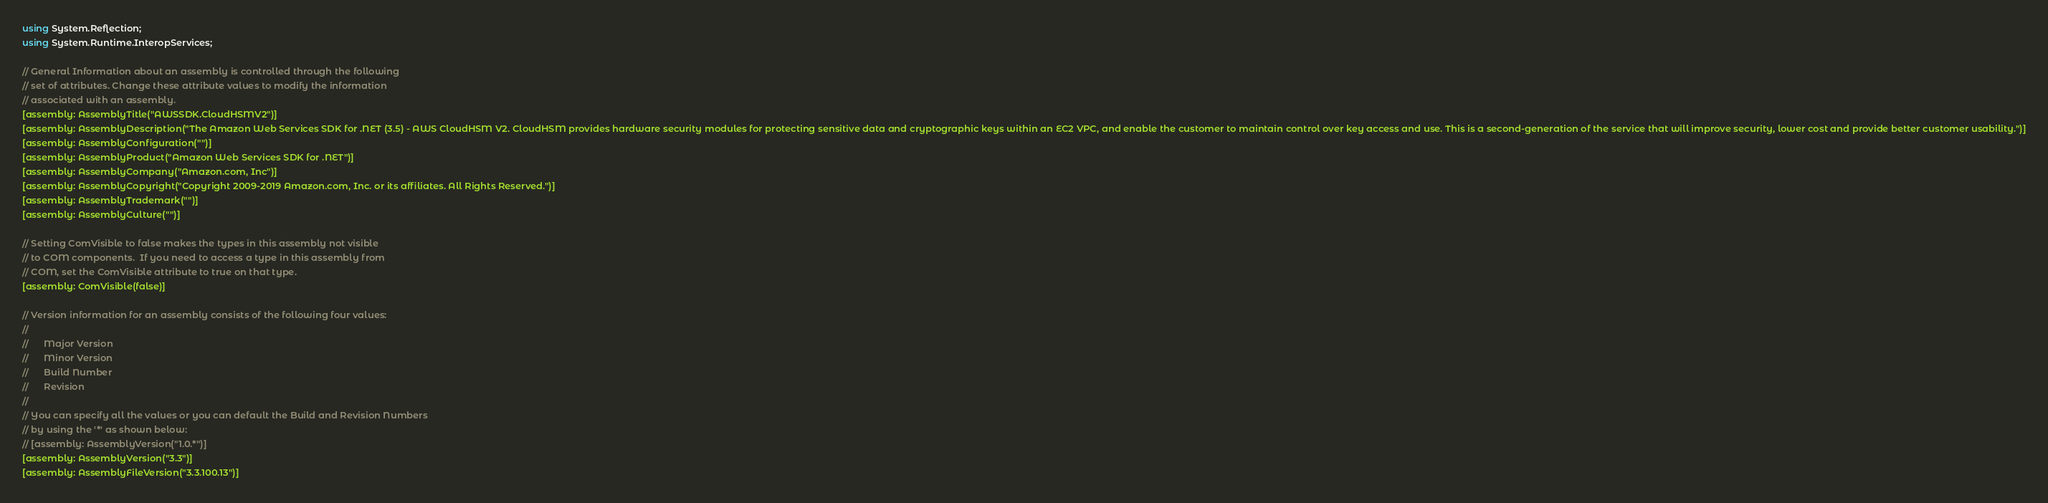<code> <loc_0><loc_0><loc_500><loc_500><_C#_>using System.Reflection;
using System.Runtime.InteropServices;

// General Information about an assembly is controlled through the following 
// set of attributes. Change these attribute values to modify the information
// associated with an assembly.
[assembly: AssemblyTitle("AWSSDK.CloudHSMV2")]
[assembly: AssemblyDescription("The Amazon Web Services SDK for .NET (3.5) - AWS CloudHSM V2. CloudHSM provides hardware security modules for protecting sensitive data and cryptographic keys within an EC2 VPC, and enable the customer to maintain control over key access and use. This is a second-generation of the service that will improve security, lower cost and provide better customer usability.")]
[assembly: AssemblyConfiguration("")]
[assembly: AssemblyProduct("Amazon Web Services SDK for .NET")]
[assembly: AssemblyCompany("Amazon.com, Inc")]
[assembly: AssemblyCopyright("Copyright 2009-2019 Amazon.com, Inc. or its affiliates. All Rights Reserved.")]
[assembly: AssemblyTrademark("")]
[assembly: AssemblyCulture("")]

// Setting ComVisible to false makes the types in this assembly not visible 
// to COM components.  If you need to access a type in this assembly from 
// COM, set the ComVisible attribute to true on that type.
[assembly: ComVisible(false)]

// Version information for an assembly consists of the following four values:
//
//      Major Version
//      Minor Version 
//      Build Number
//      Revision
//
// You can specify all the values or you can default the Build and Revision Numbers 
// by using the '*' as shown below:
// [assembly: AssemblyVersion("1.0.*")]
[assembly: AssemblyVersion("3.3")]
[assembly: AssemblyFileVersion("3.3.100.13")]</code> 